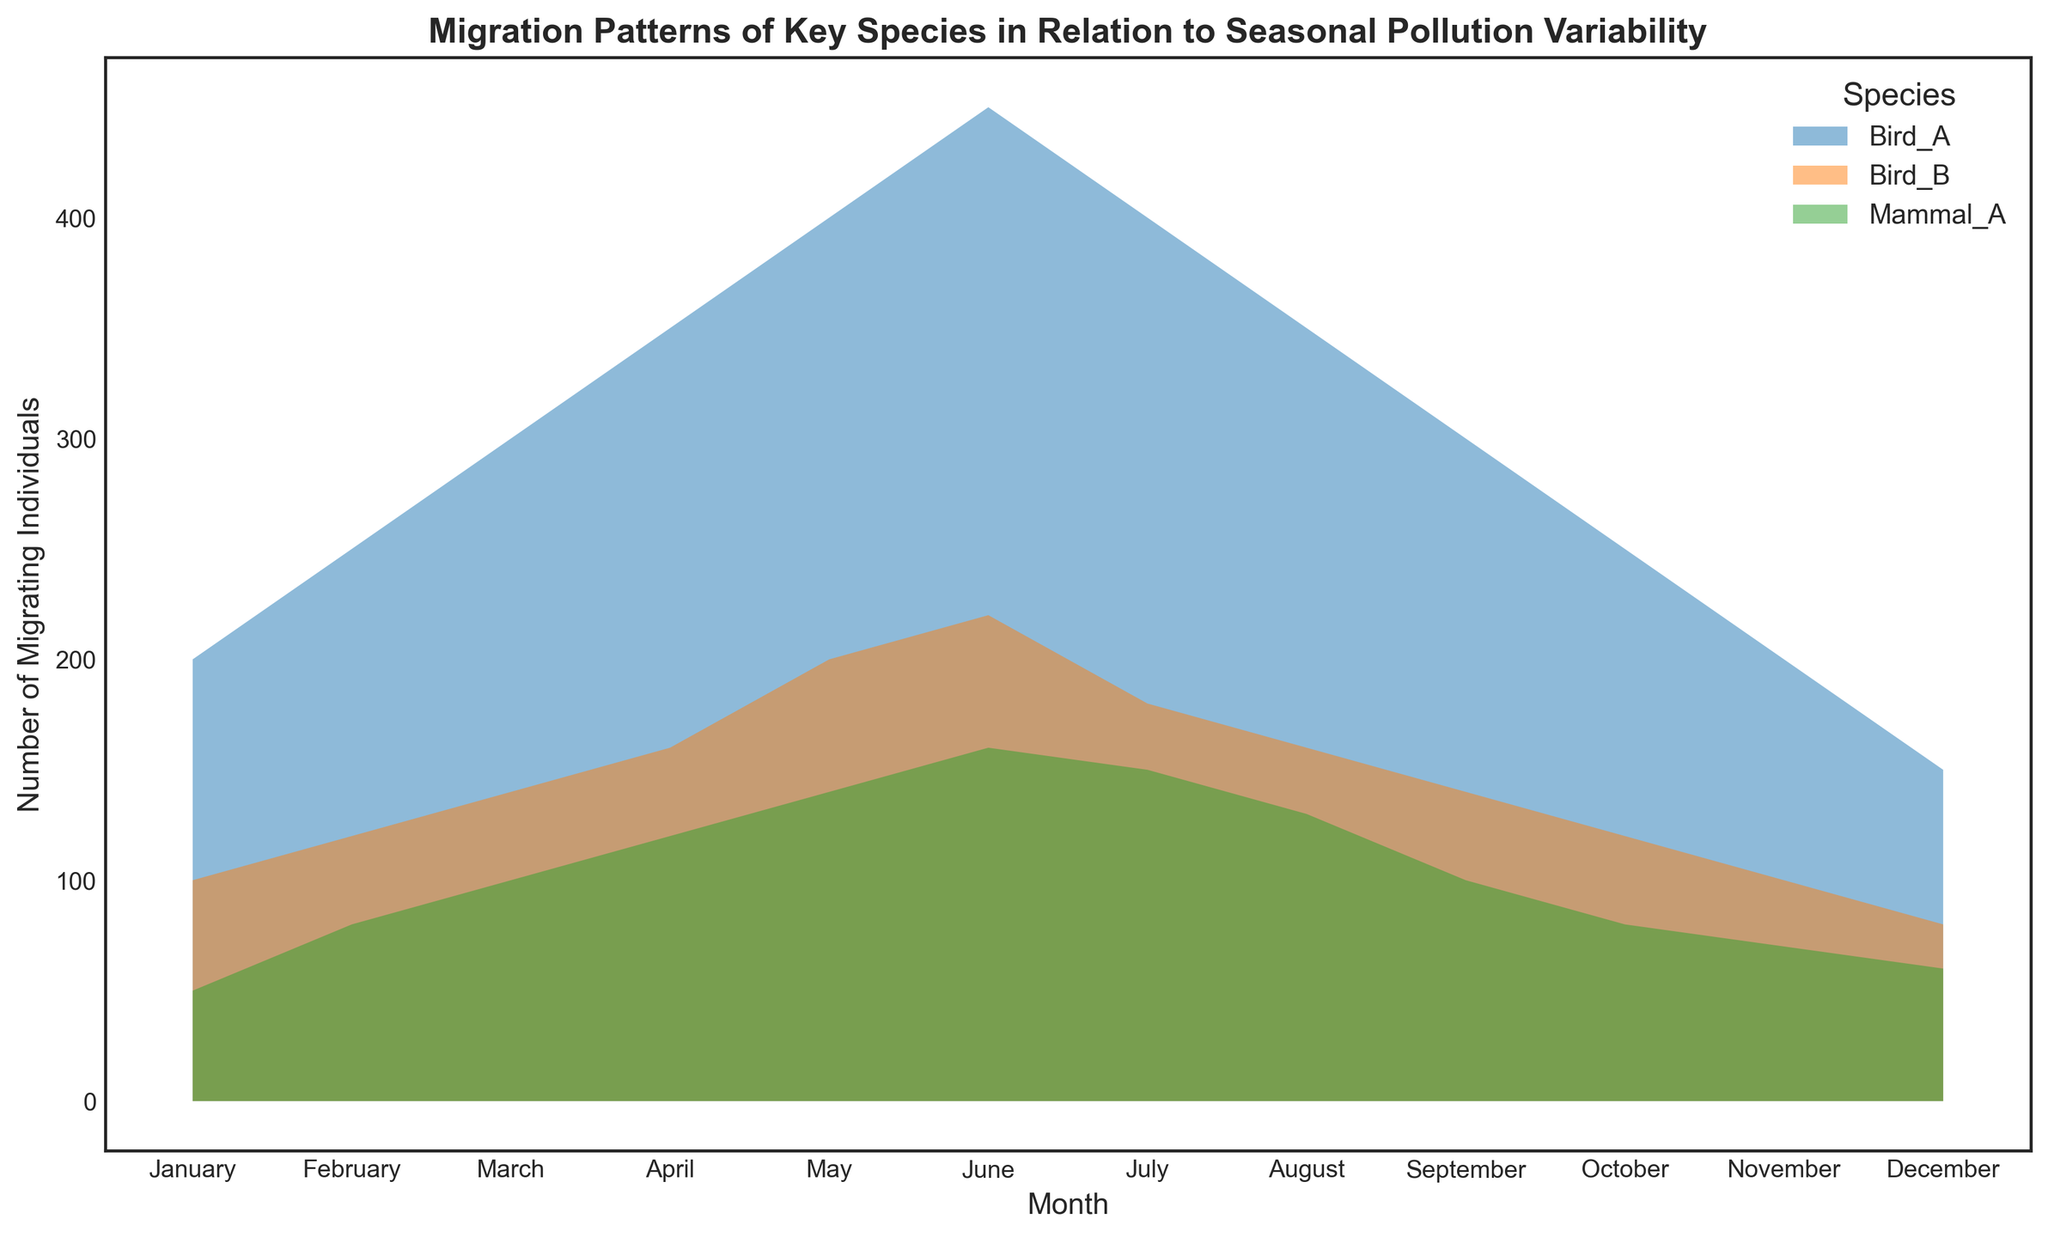What is the average number of migrating individuals for Bird_A across all months? To calculate the average number of migrating individuals for Bird_A, sum up the values for each month (200 + 250 + 300 + 350 + 400 + 450 + 400 + 350 + 300 + 250 + 200 + 150 = 3600) and then divide by the number of months (12). The average is 3600 / 12 = 300.
Answer: 300 Which species has the highest number of migrating individuals in June? Look at the plot and compare the height of the filled areas corresponding to June for Bird_A, Bird_B, and Mammal_A. Bird_A has the highest filled area in June.
Answer: Bird_A How does the pollution level trend relate to the migration pattern of Bird_B? Looking at the plot, you see that the number of migrating individuals of Bird_B increases as pollution levels decrease from January to July. When pollution increases from August to December, the number of migrating individuals decreases.
Answer: Inversely correlated What is the difference in migrating individuals between Bird_A in May and Mammal_A in May? Identify the number of migrating individuals for Bird_A (400) and Mammal_A (140) in May. Subtract the lower value from the higher value: 400 - 140.
Answer: 260 Which species shows the least variation in migrating individuals throughout the year? Assess the height changes of the filled areas for each species across all months. Mammal_A shows the least variation because the height changes are less pronounced compared to Bird_A and Bird_B.
Answer: Mammal_A Among the three species, which had the lowest migration in December? Compare the heights of the filled areas corresponding to December for Bird_A, Bird_B, and Mammal_A. Bird_B has the lowest filled area in December.
Answer: Bird_B In which month does Mammal_A have its peak migration and what is the pollution level at that time? Find the month where the filled area for Mammal_A is the highest. The peak migration for Mammal_A is in June, and the pollution level at that time is 8.
Answer: June, 8 If the pollution level suddenly rises to 30 units in July, how might the migration pattern of Bird_A likely change compared to the visual trends? Based on the plotted trend, an increase in pollution level has generally led to a decrease in the number of migrating Bird_A. Thus, a sudden rise to 30 units in July would likely result in a reduced number of migrating individuals compared to current July levels.
Answer: Likely decrease Compare the migration patterns of Bird_A and Bird_B in terms of their fluctuations across months. Assess the filled areas' height changes for both Bird_A and Bird_B. Bird_A shows larger fluctuations, peaking in June and then declining, whereas Bird_B shows moderate fluctuations with less intense peaks and troughs.
Answer: Bird_A has larger fluctuations 